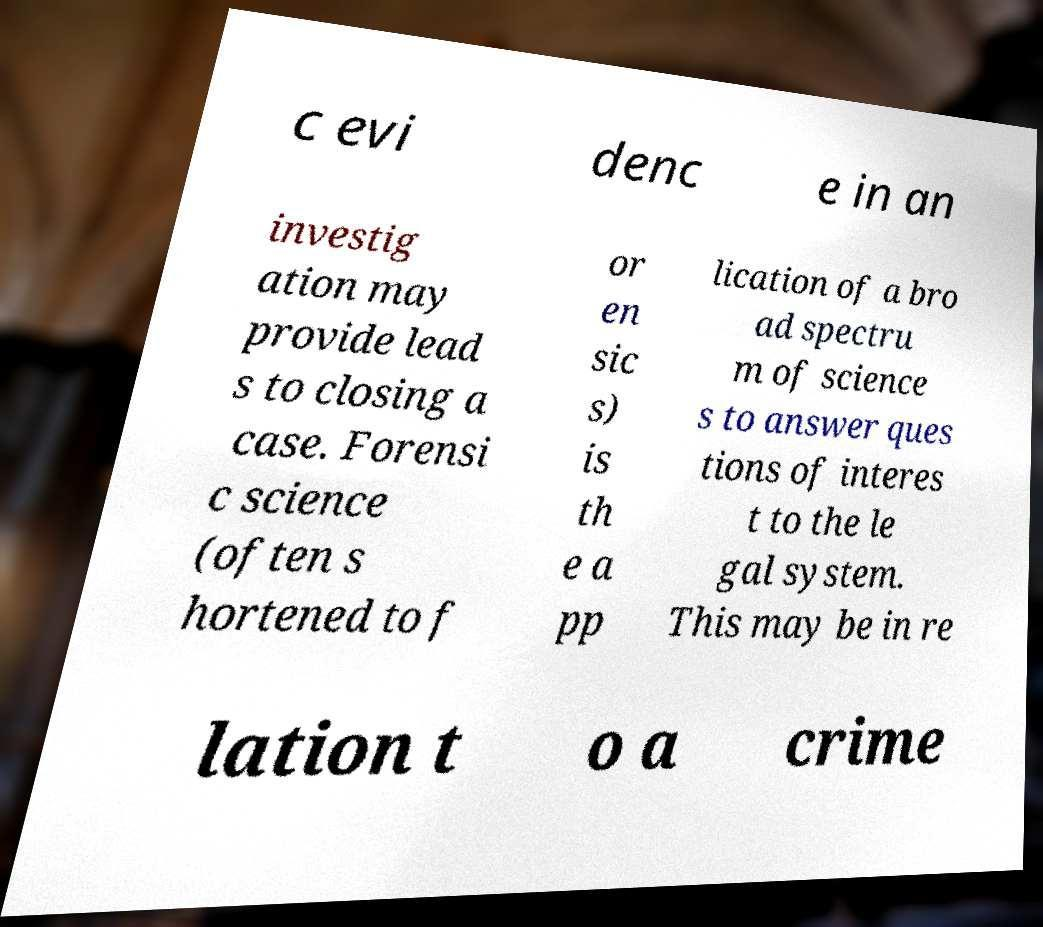Could you extract and type out the text from this image? c evi denc e in an investig ation may provide lead s to closing a case. Forensi c science (often s hortened to f or en sic s) is th e a pp lication of a bro ad spectru m of science s to answer ques tions of interes t to the le gal system. This may be in re lation t o a crime 